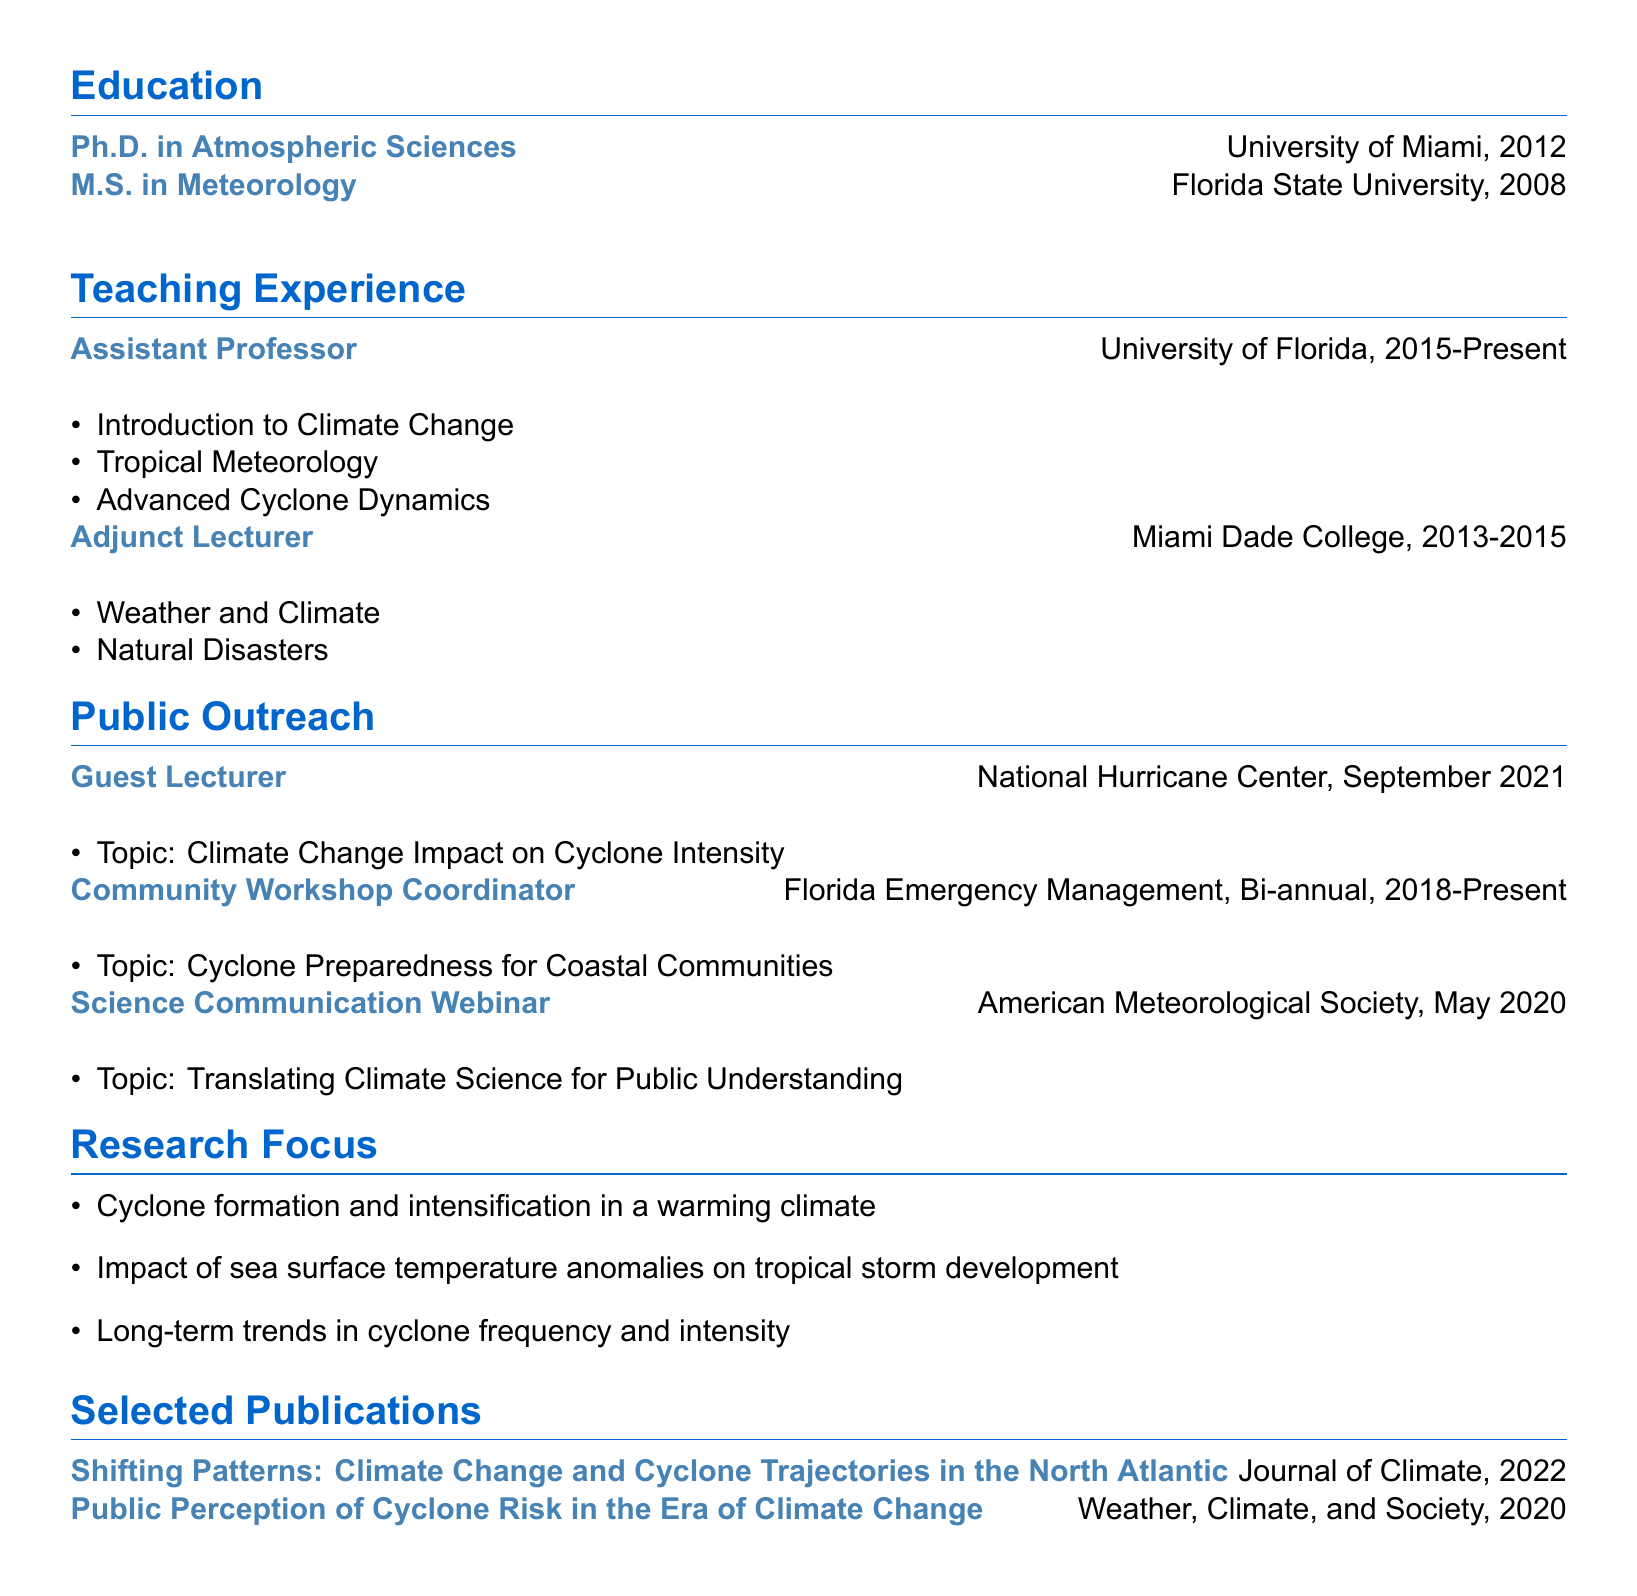what is Dr. Samantha Martinez's title? The title is stated in the personal information section of the document.
Answer: Climate Scientist and Cyclone Expert where did Dr. Martinez obtain her Ph.D.? The institution providing the Ph.D. degree is listed in the education section.
Answer: University of Miami how many courses does Dr. Martinez teach as an Assistant Professor? The number of courses taught is found in the teaching experience section under her position.
Answer: Three what is the frequency of the community workshops coordinated by Dr. Martinez? This information is provided in the public outreach activities section, detailing the workshop schedule.
Answer: Bi-annual in what year did Dr. Martinez give a guest lecture at the National Hurricane Center? The date of the guest lecture is mentioned in the public outreach section.
Answer: September 2021 which organization did Dr. Martinez collaborate with for a science communication webinar? The organization is revealed in the public outreach section detailing the webinar activity.
Answer: American Meteorological Society what is one of the research focuses of Dr. Martinez? The research focus points are shown in a specific section and need to be summarized.
Answer: Cyclone formation and intensification in a warming climate which journal published Dr. Martinez's article on cyclone trajectories? The journal name is provided in the selected publications section of the document.
Answer: Journal of Climate 